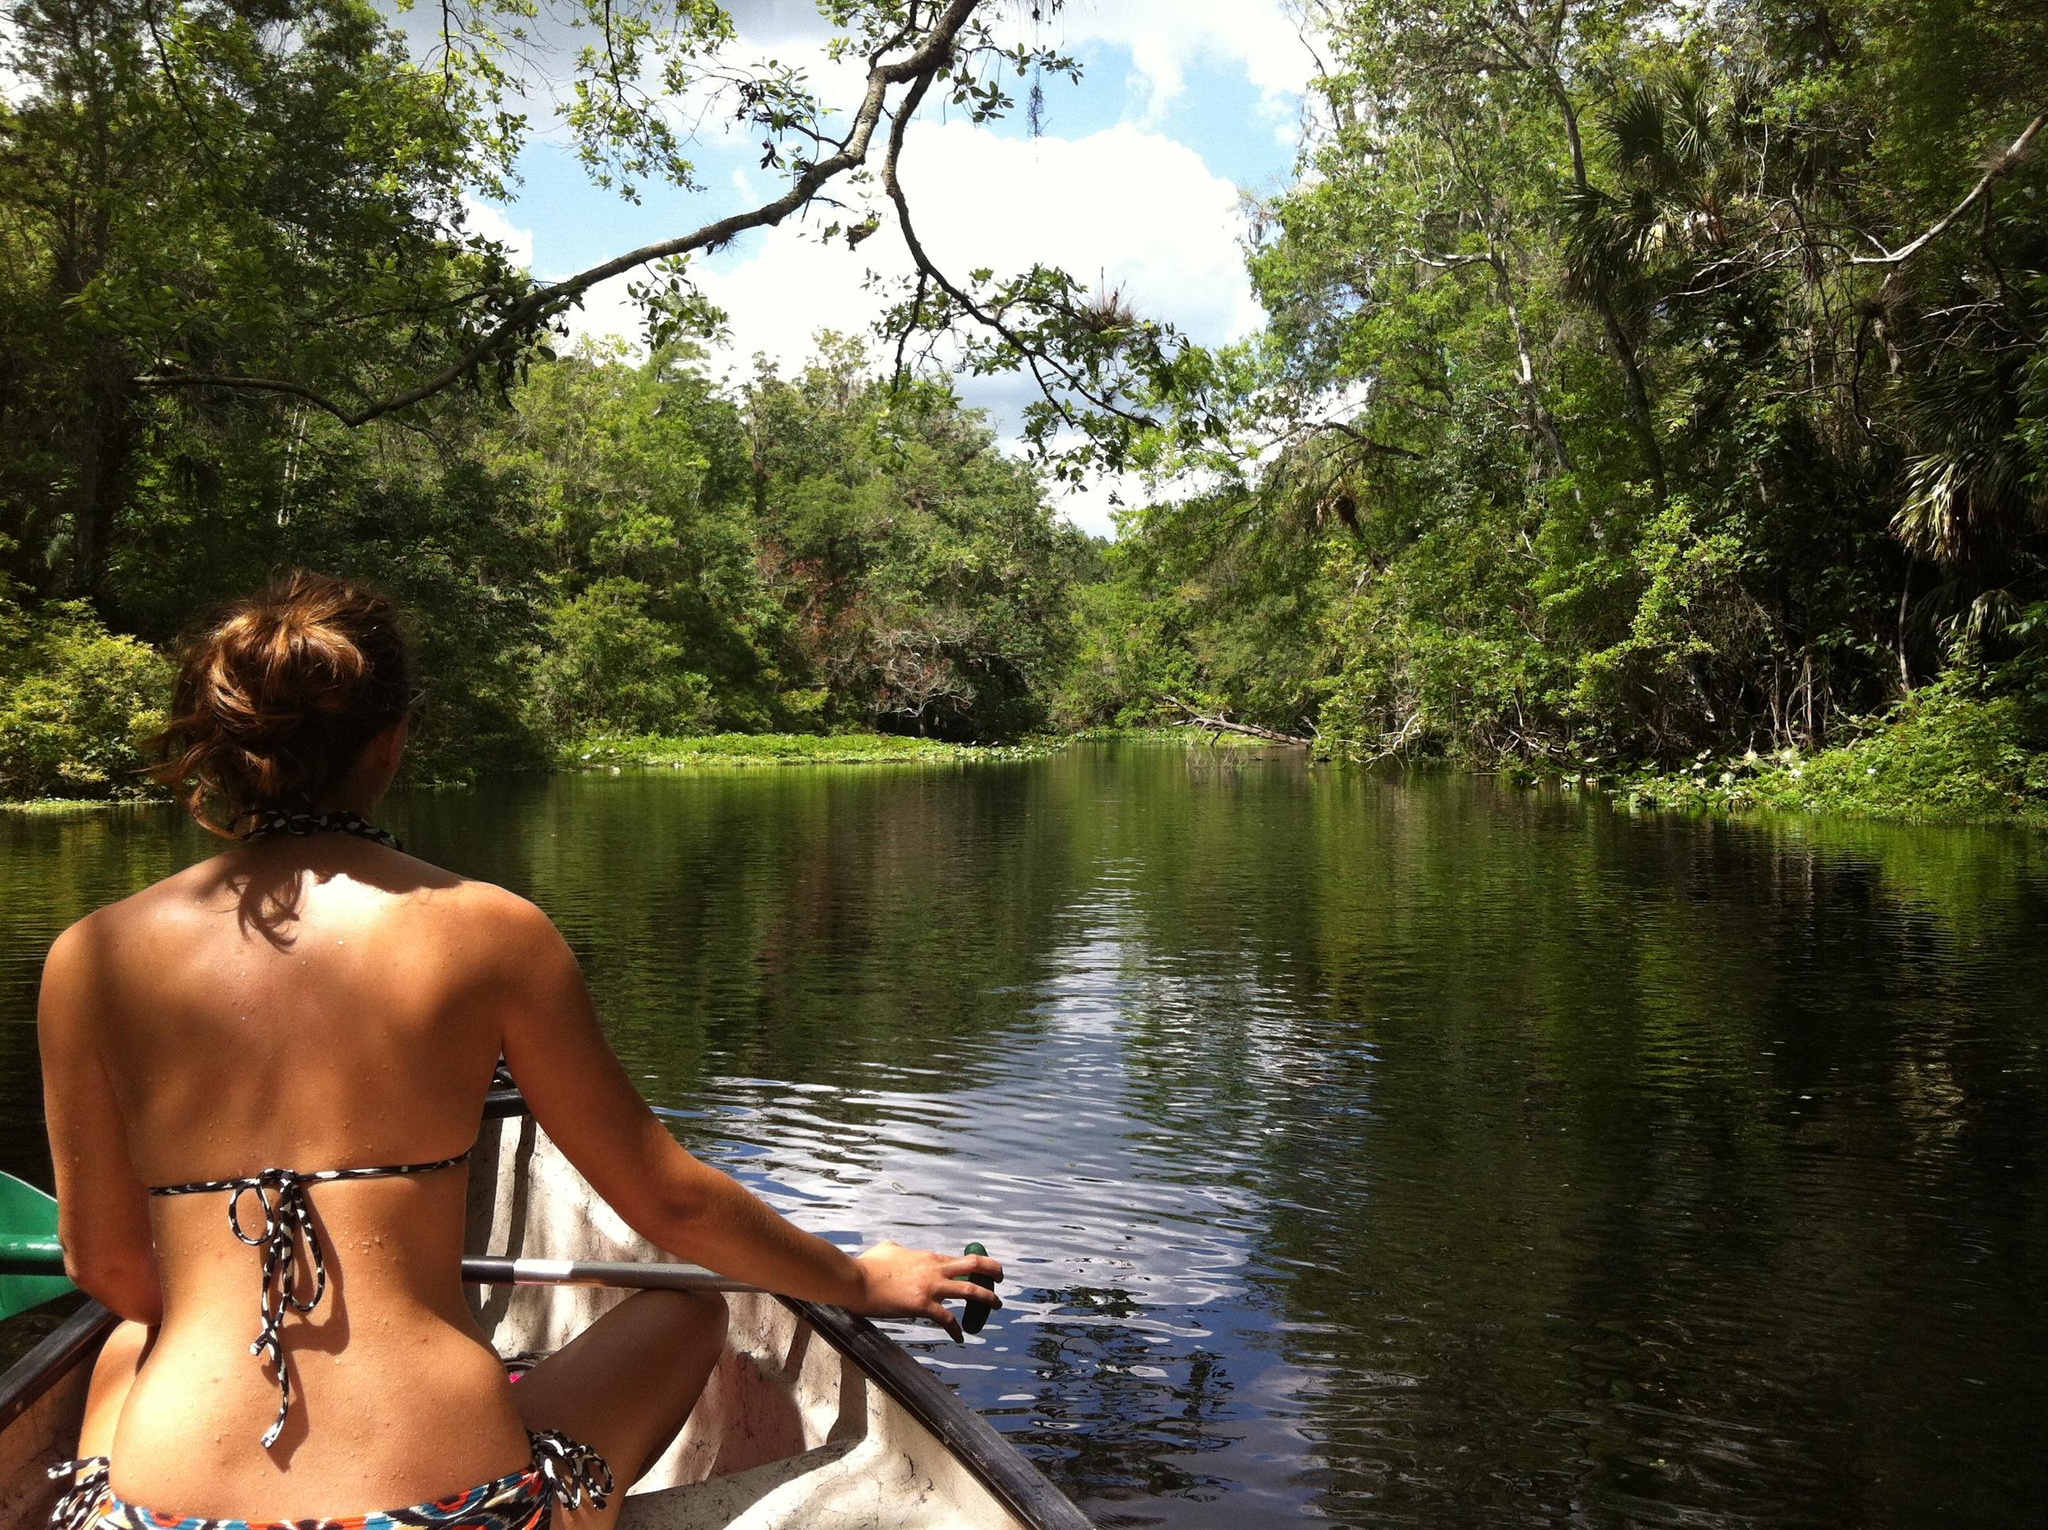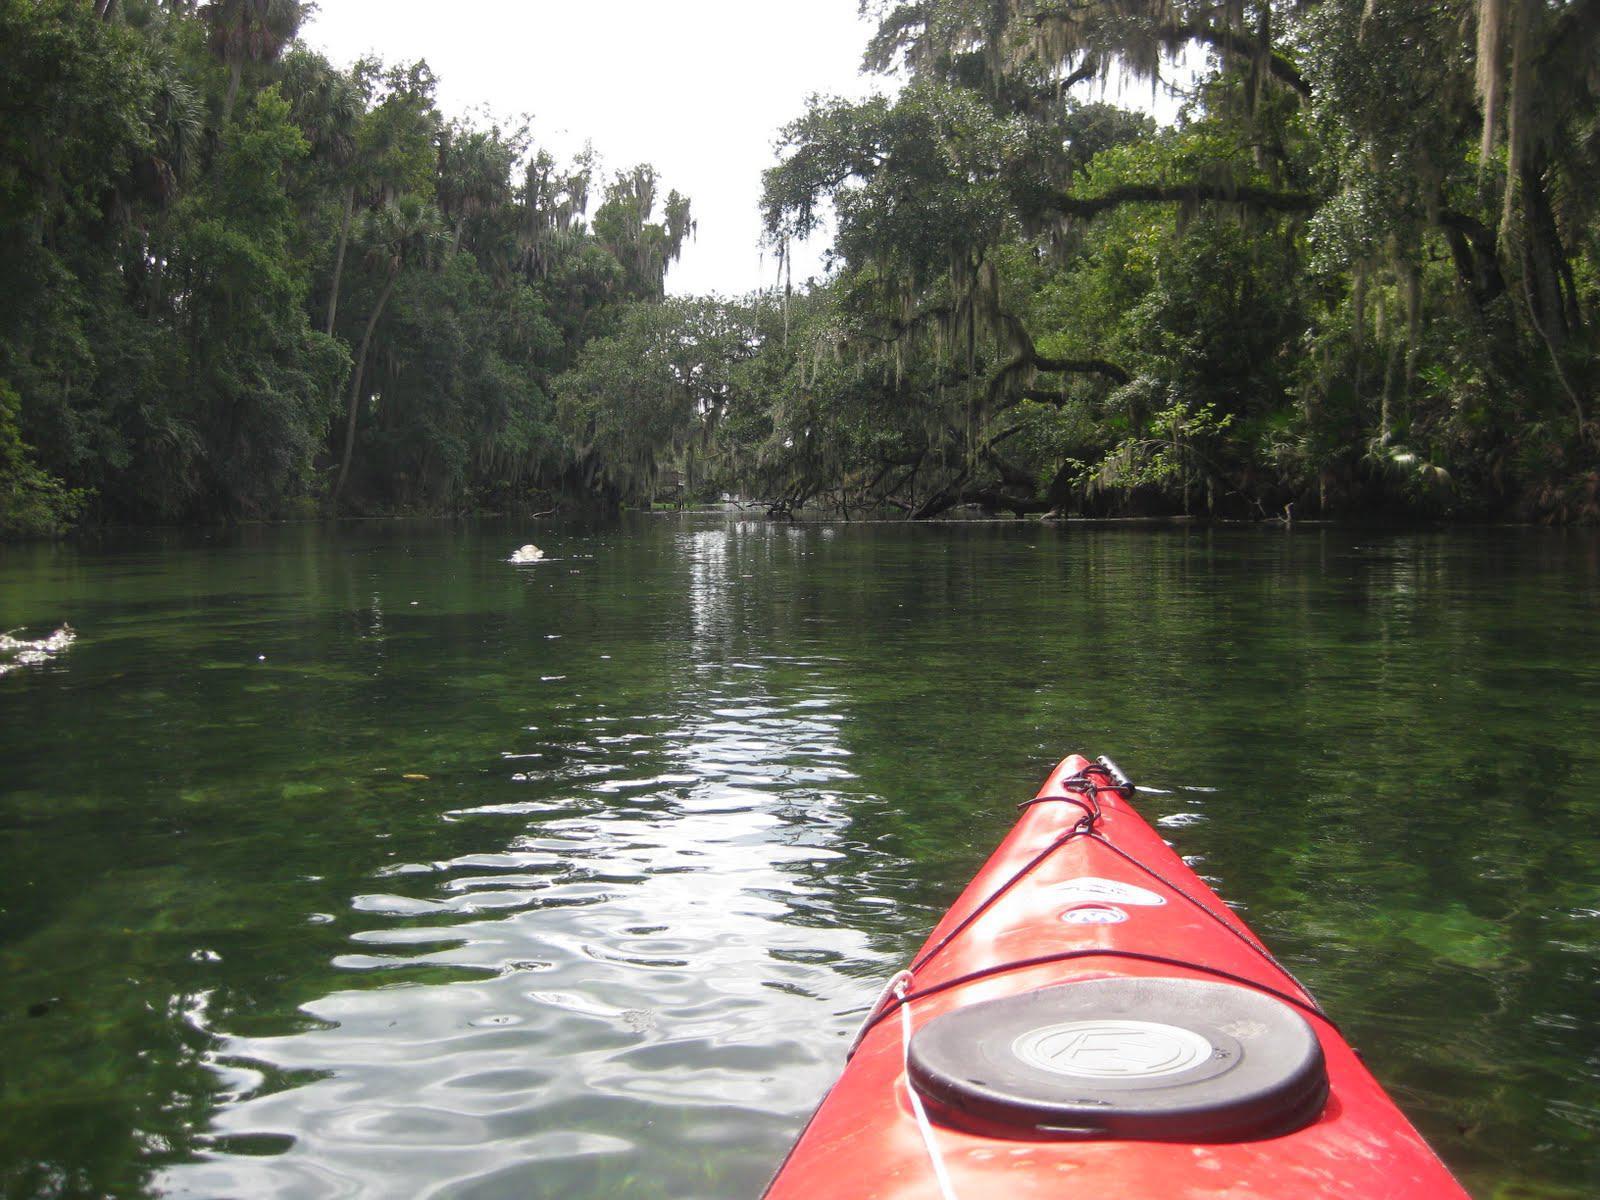The first image is the image on the left, the second image is the image on the right. Considering the images on both sides, is "There is no more than one human in the right image wearing a hat." valid? Answer yes or no. No. 